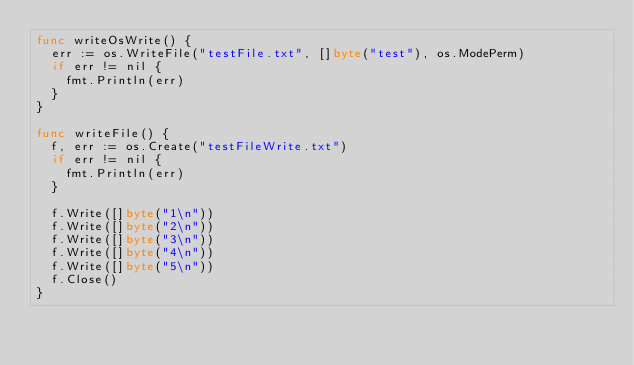Convert code to text. <code><loc_0><loc_0><loc_500><loc_500><_Go_>func writeOsWrite() {
	err := os.WriteFile("testFile.txt", []byte("test"), os.ModePerm)
	if err != nil {
		fmt.Println(err)
	}
}

func writeFile() {
	f, err := os.Create("testFileWrite.txt")
	if err != nil {
		fmt.Println(err)
	}

	f.Write([]byte("1\n"))
	f.Write([]byte("2\n"))
	f.Write([]byte("3\n"))
	f.Write([]byte("4\n"))
	f.Write([]byte("5\n"))
	f.Close()
}</code> 